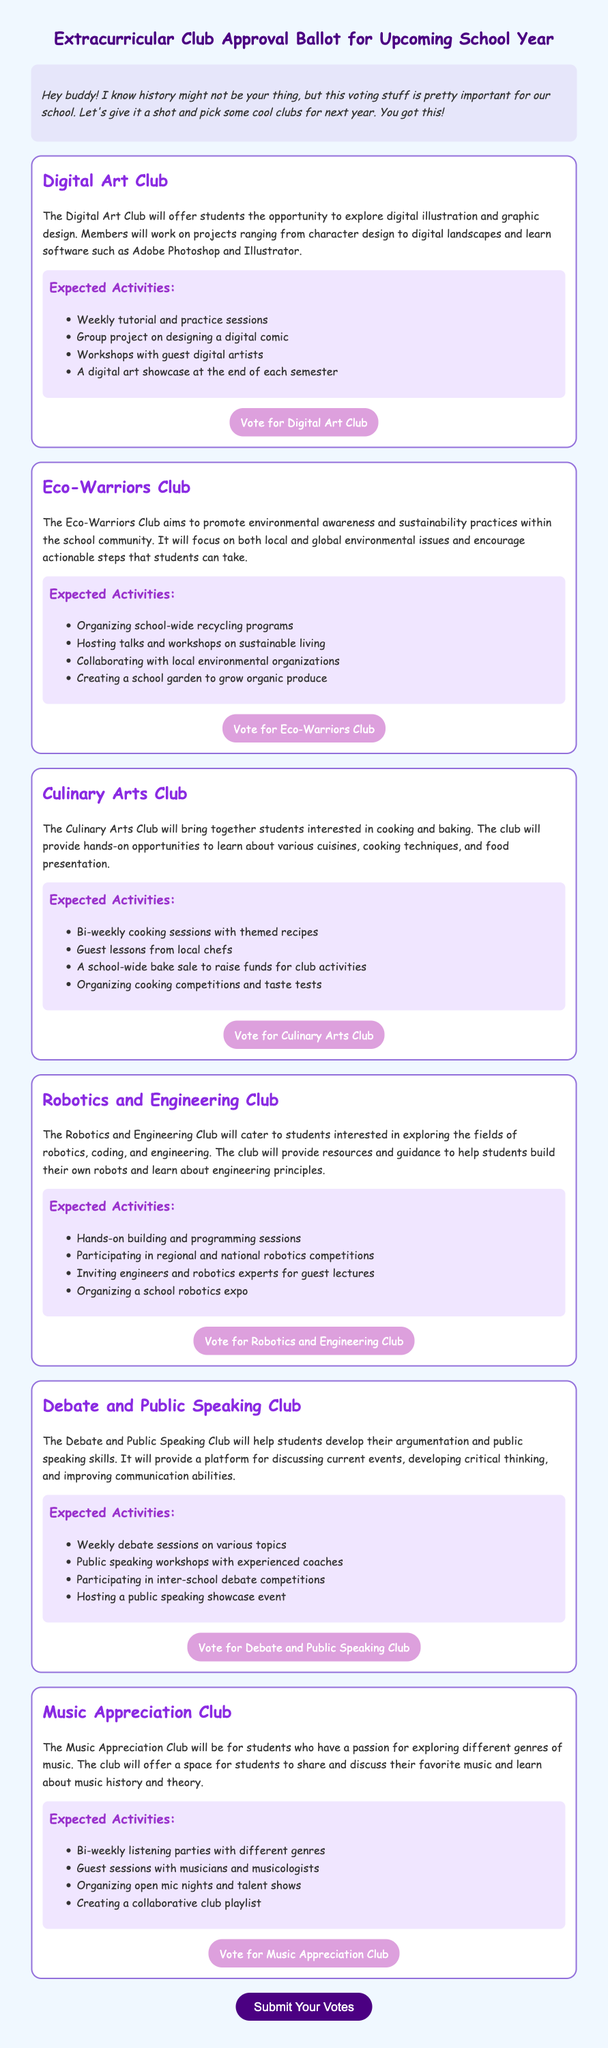What is the title of the document? The title of the document is found at the top of the rendered page, which describes the subject matter.
Answer: Extracurricular Club Approval Ballot for Upcoming School Year How many clubs are listed in the ballot? The number of clubs can be counted from the separate sections provided for each club in the document.
Answer: Six What activity is associated with the Digital Art Club? The expected activities include weekly tutorial and practice sessions detailed under the Digital Art Club description.
Answer: Weekly tutorial and practice sessions What is the focus of the Eco-Warriors Club? The focus of the Eco-Warriors Club is summarized in the club's description about its goals related to environmental awareness.
Answer: Environmental awareness and sustainability practices Which club involves cooking competitions? The club that mentions organizing cooking competitions is specifically highlighted in its description about engaging students in food-related activities.
Answer: Culinary Arts Club Who will conduct guest sessions for the Music Appreciation Club? The guest sessions for the Music Appreciation Club will be conducted by individuals who have experience in music, as stated in the club's activities section.
Answer: Musicians and musicologists What type of event does the Debate and Public Speaking Club plan to host? This specific club aims to host a particular type of event that encourages public speaking skills as highlighted in its expected activities.
Answer: Public speaking showcase event What is the purpose of the Robotics and Engineering Club? The purpose of this club is directly mentioned in the club description concerning the main interests it caters to for students.
Answer: Exploring robotics, coding, and engineering How often will the Music Appreciation Club hold listening parties? The frequency of the listening parties is specified in the expected activities section for the Music Appreciation Club.
Answer: Bi-weekly 